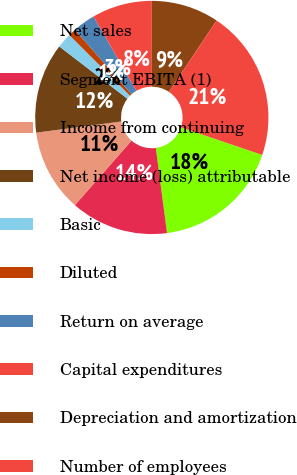Convert chart. <chart><loc_0><loc_0><loc_500><loc_500><pie_chart><fcel>Net sales<fcel>Segment EBITA (1)<fcel>Income from continuing<fcel>Net income (loss) attributable<fcel>Basic<fcel>Diluted<fcel>Return on average<fcel>Capital expenditures<fcel>Depreciation and amortization<fcel>Number of employees<nl><fcel>17.71%<fcel>13.54%<fcel>11.46%<fcel>12.5%<fcel>2.08%<fcel>1.04%<fcel>3.13%<fcel>8.33%<fcel>9.38%<fcel>20.83%<nl></chart> 